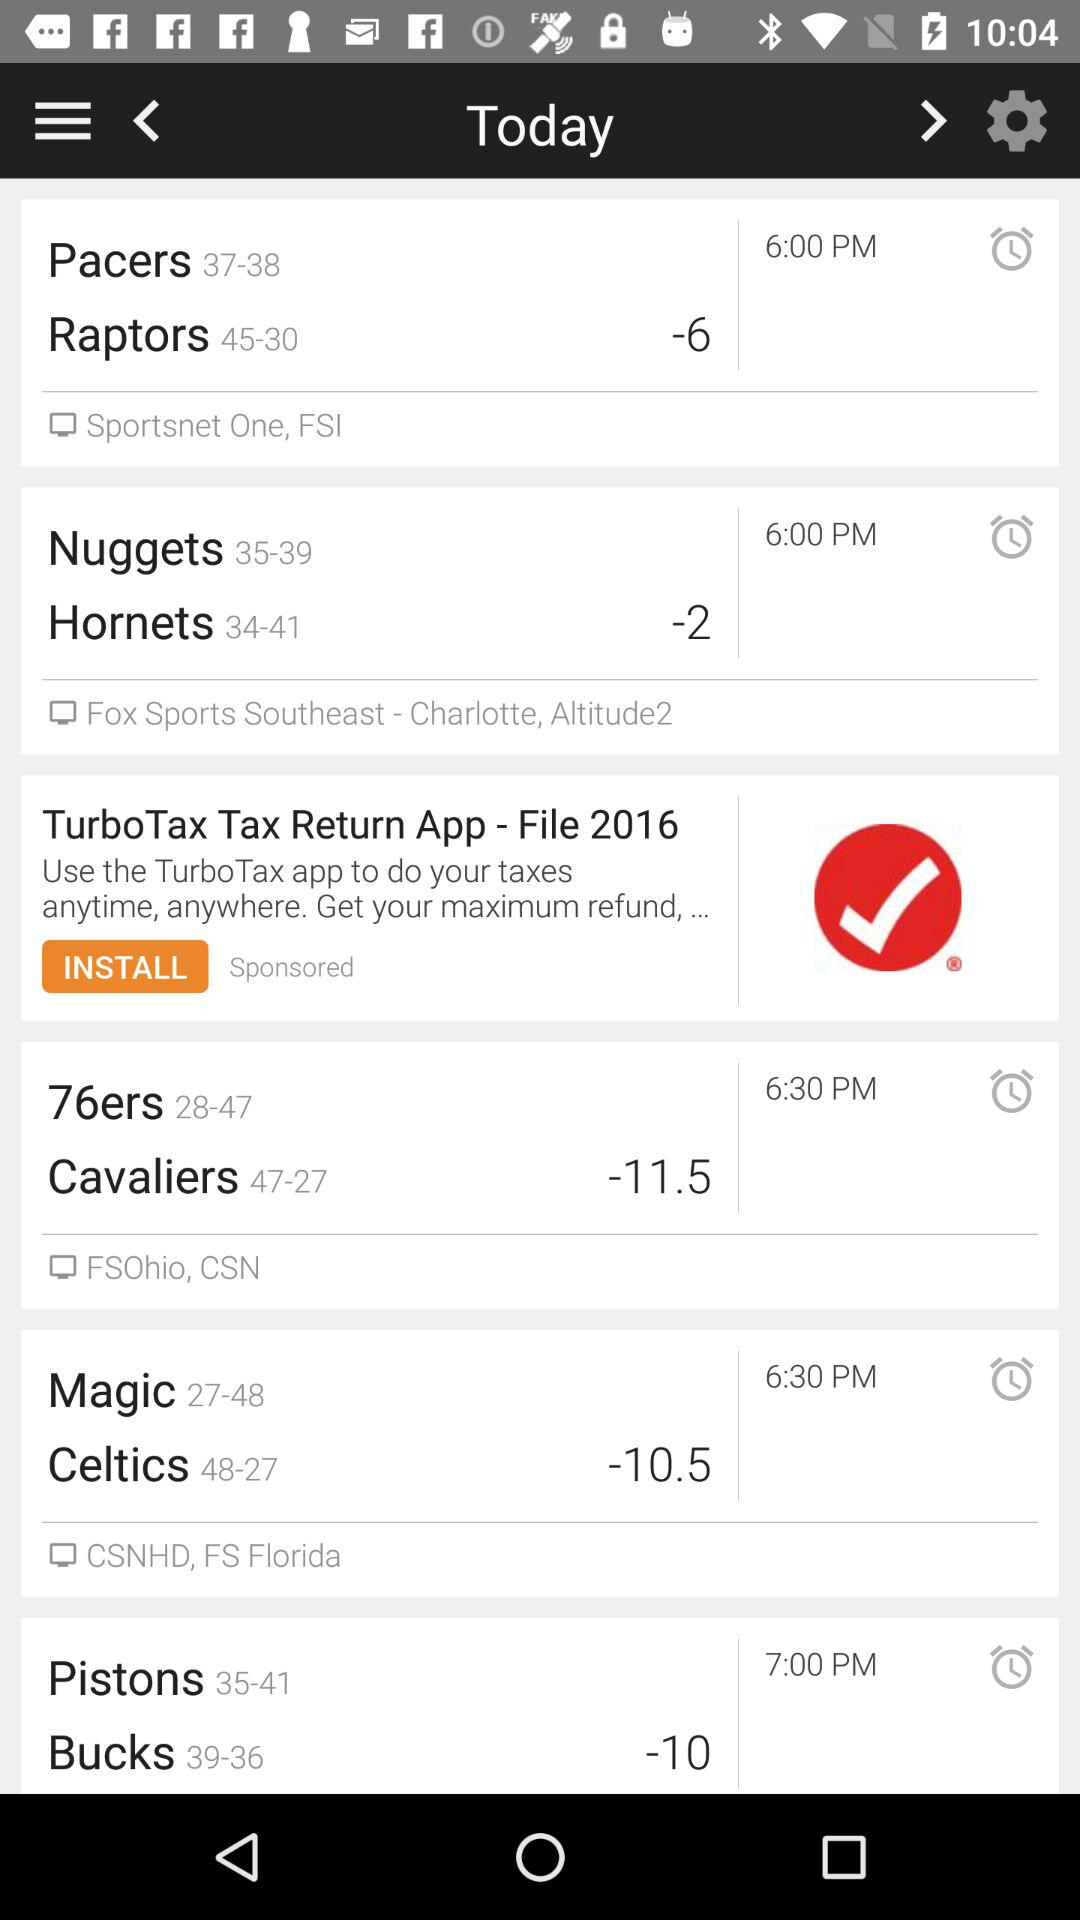What's the alarm for Pacers?
When the provided information is insufficient, respond with <no answer>. <no answer> 